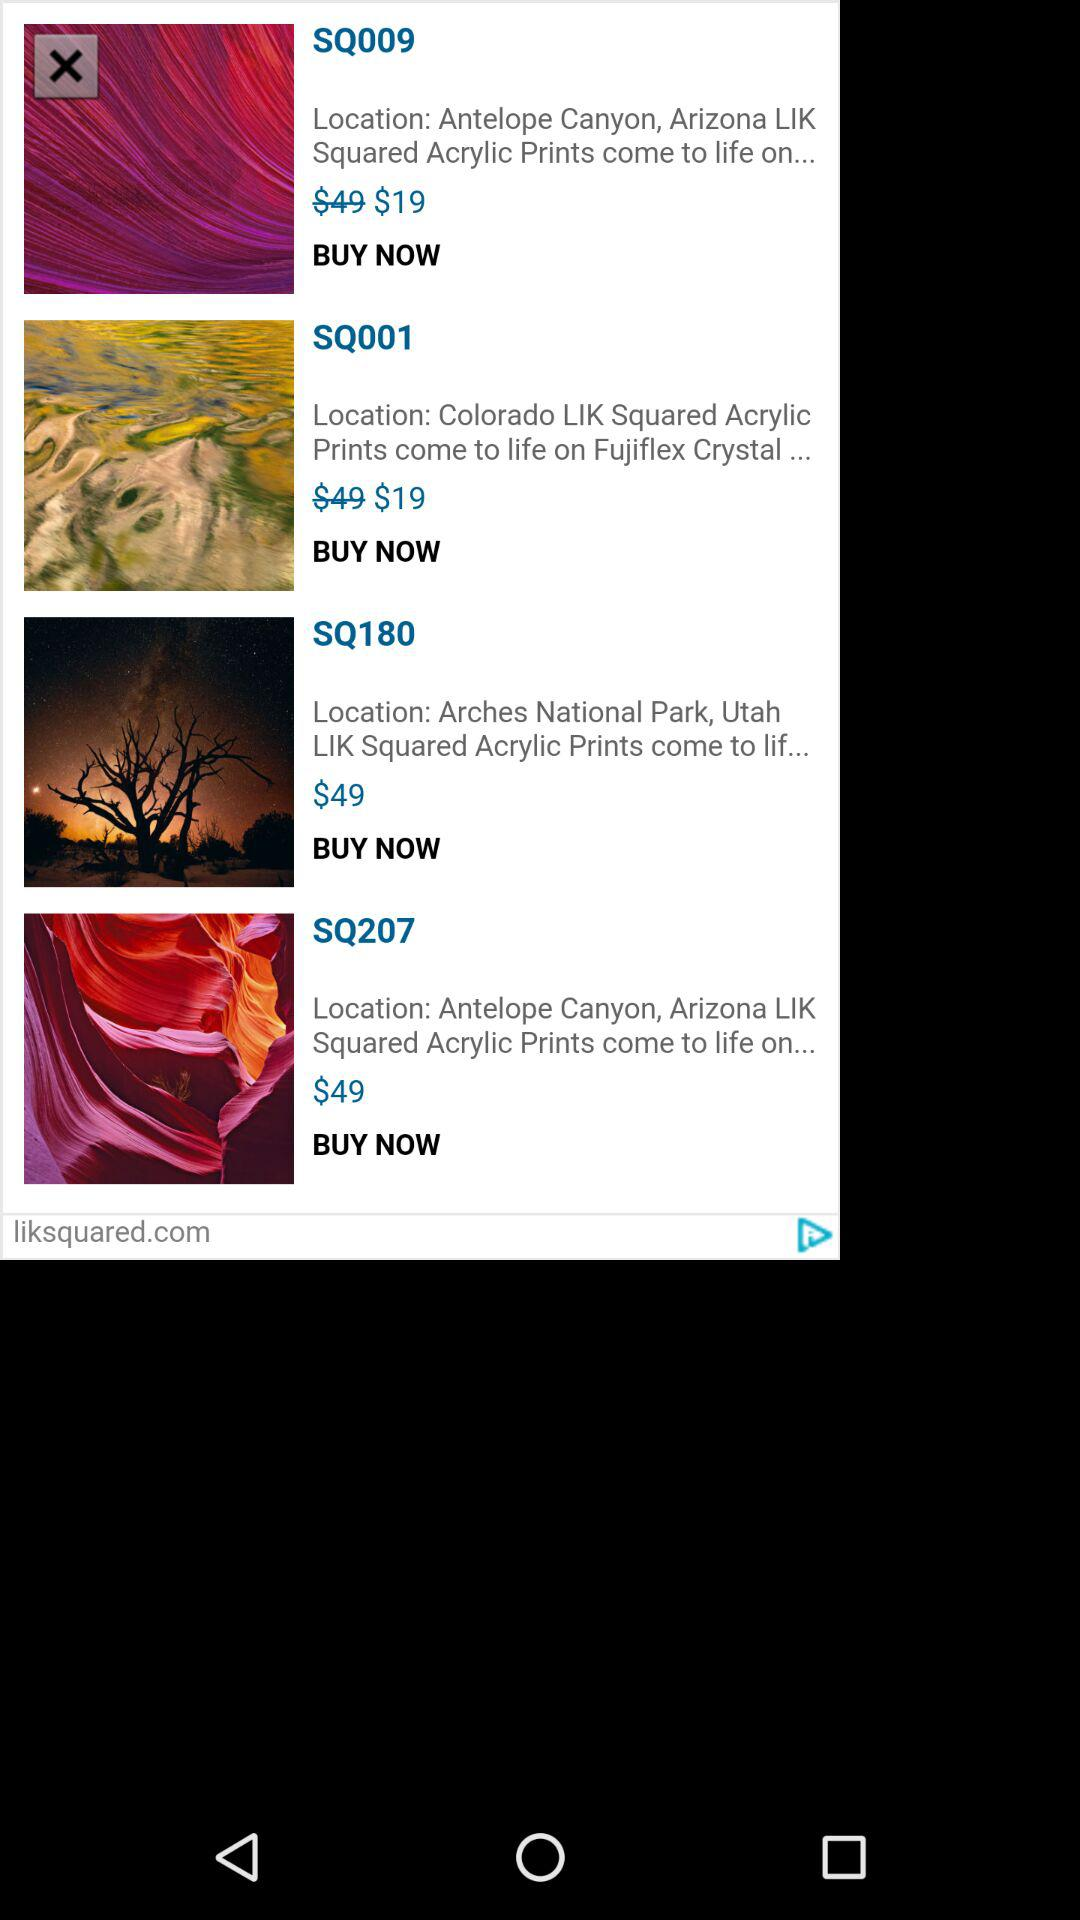How many more dollars are the most expensive item and the least expensive item?
Answer the question using a single word or phrase. 30 